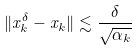<formula> <loc_0><loc_0><loc_500><loc_500>\| x _ { k } ^ { \delta } - x _ { k } \| \lesssim \frac { \delta } { \sqrt { \alpha _ { k } } }</formula> 